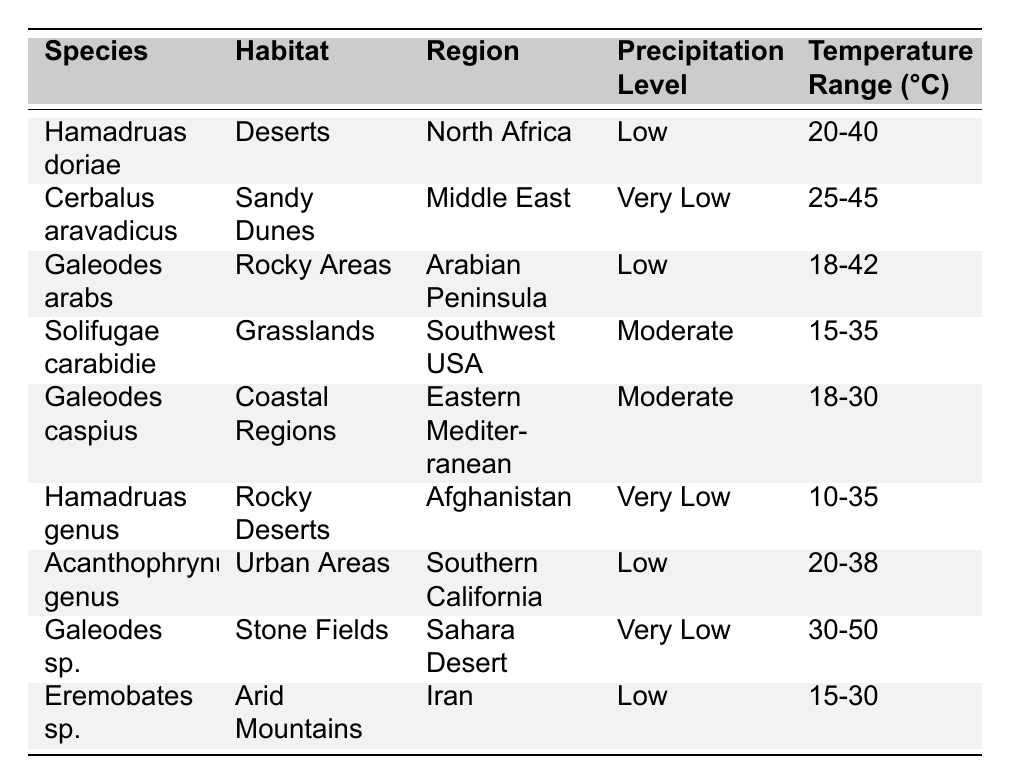What is the habitat of Galeodes caspius? From the table, the habitat listed next to the species Galeodes caspius is "Coastal Regions".
Answer: Coastal Regions Which species has the highest temperature range? By examining the temperature ranges in the table, Galeodes sp. displays a range of 30-50°C, which is the highest among the listed species.
Answer: Galeodes sp Are there any camel spider species found in Urban Areas? In the table, one species, Acanthophrynus genus, is noted to inhabit Urban Areas. Thus, the answer is yes.
Answer: Yes What is the precipitation level for the species found in Rocky Deserts? The table shows that Hamadruas genus, which is found in Rocky Deserts, has a precipitation level categorized as "Very Low".
Answer: Very Low How many species have a "Low" precipitation level? In the table, there are four species with a "Low" precipitation level: Hamadruas doriae, Galeodes arabs, Acanthophrynus genus, and Eremobates sp. Thus, there are 4 species in total.
Answer: 4 Which region has a camel spider species that tolerates a temperature range of 15-30°C? The table indicates that Eremobates sp. is found in the region of Iran and has a temperature range of 15-30°C.
Answer: Iran Is there any camel spider species with a "Moderate" precipitation level, and if so, what are they? The table lists two species with "Moderate" precipitation levels: Solifugae carabidie and Galeodes caspius. Therefore, there are indeed species in this category.
Answer: Yes, Solifugae carabidie and Galeodes caspius What is the difference between the lowest and highest temperature range among the species? The lowest temperature range from any species is 10-35°C (Hamadruas genus), and the highest is 30-50°C (Galeodes sp.). The difference in ranges is calculated as (50 - 10) = 40°C.
Answer: 40°C How many species are found in the Sahara Desert, and what are they? The table shows Galeodes sp. as the only species located in the Sahara Desert. Therefore, there is 1 species present in this region.
Answer: 1 species: Galeodes sp Which camel spider species can tolerate the widest temperature variation? Galeodes sp. exhibits the widest temperature range from 30-50°C. This range is broader than any other listed in the table.
Answer: Galeodes sp 